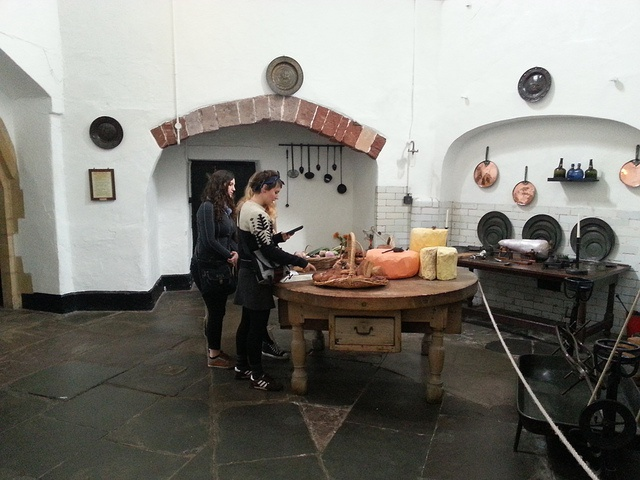Describe the objects in this image and their specific colors. I can see dining table in white, gray, tan, maroon, and black tones, people in white, black, gray, and darkgray tones, people in white, black, and gray tones, handbag in black and white tones, and handbag in white, black, gray, and darkgray tones in this image. 